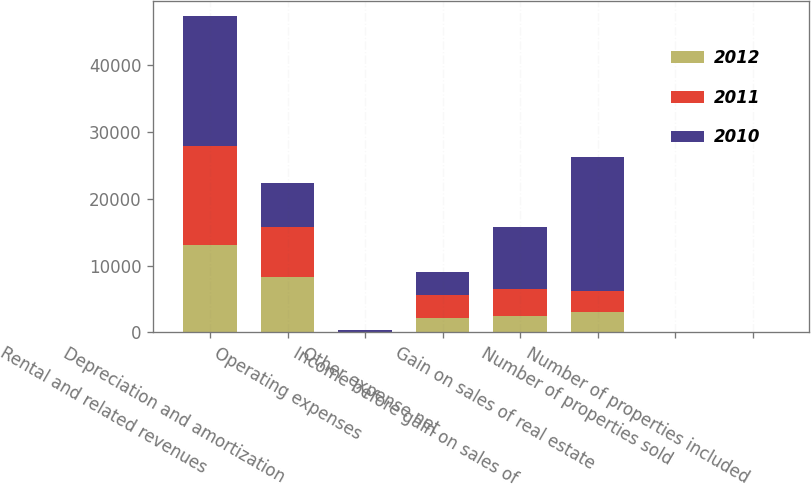<chart> <loc_0><loc_0><loc_500><loc_500><stacked_bar_chart><ecel><fcel>Rental and related revenues<fcel>Depreciation and amortization<fcel>Operating expenses<fcel>Other expense net<fcel>Income before gain on sales of<fcel>Gain on sales of real estate<fcel>Number of properties sold<fcel>Number of properties included<nl><fcel>2012<fcel>13025<fcel>8267<fcel>22<fcel>2232<fcel>2504<fcel>3107<fcel>4<fcel>4<nl><fcel>2011<fcel>14877<fcel>7473<fcel>22<fcel>3333<fcel>4049<fcel>3107<fcel>3<fcel>7<nl><fcel>2010<fcel>19293<fcel>6513<fcel>263<fcel>3393<fcel>9124<fcel>19925<fcel>14<fcel>21<nl></chart> 